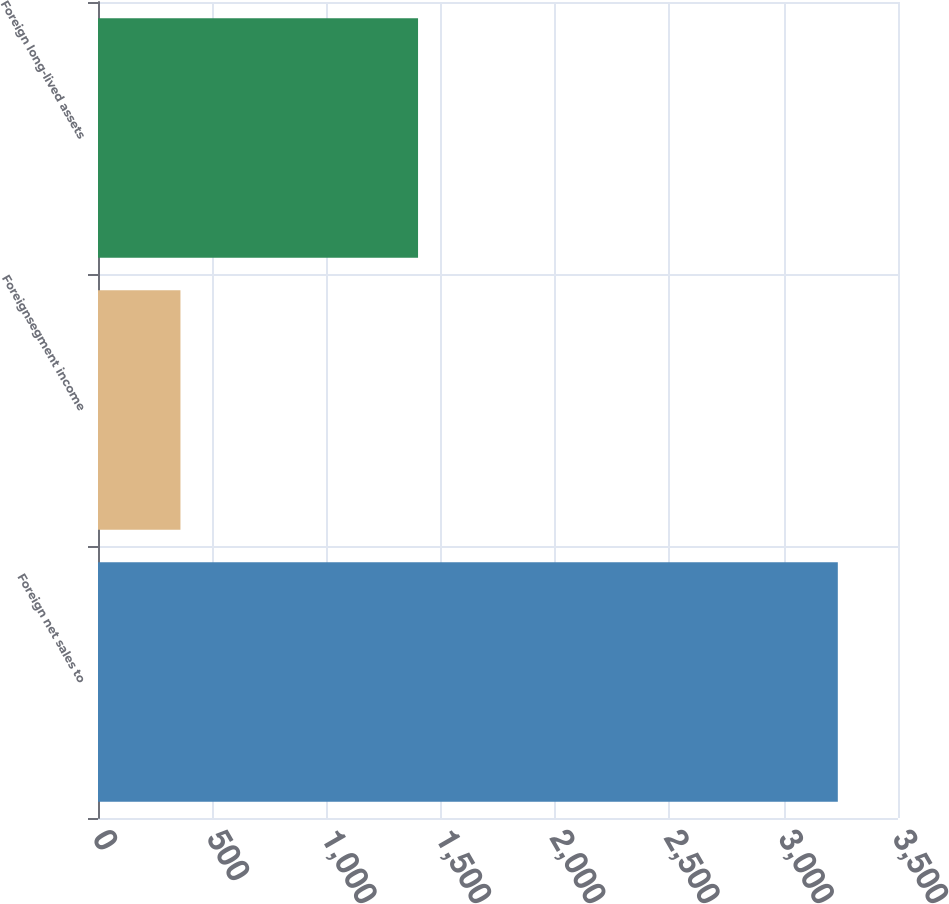Convert chart. <chart><loc_0><loc_0><loc_500><loc_500><bar_chart><fcel>Foreign net sales to<fcel>Foreignsegment income<fcel>Foreign long-lived assets<nl><fcel>3236.7<fcel>360.7<fcel>1400.2<nl></chart> 